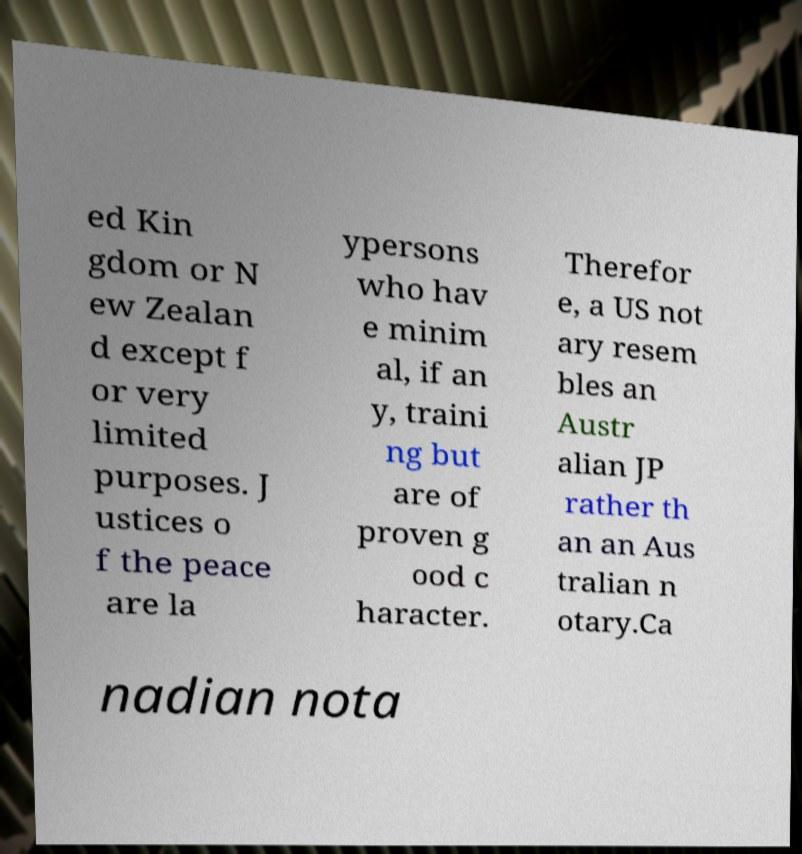Please identify and transcribe the text found in this image. ed Kin gdom or N ew Zealan d except f or very limited purposes. J ustices o f the peace are la ypersons who hav e minim al, if an y, traini ng but are of proven g ood c haracter. Therefor e, a US not ary resem bles an Austr alian JP rather th an an Aus tralian n otary.Ca nadian nota 